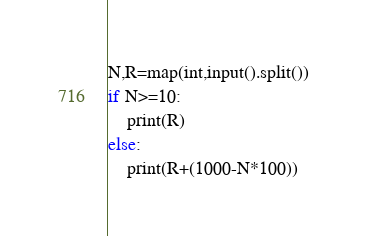Convert code to text. <code><loc_0><loc_0><loc_500><loc_500><_Python_>N,R=map(int,input().split())
if N>=10:
    print(R)
else:
    print(R+(1000-N*100))</code> 